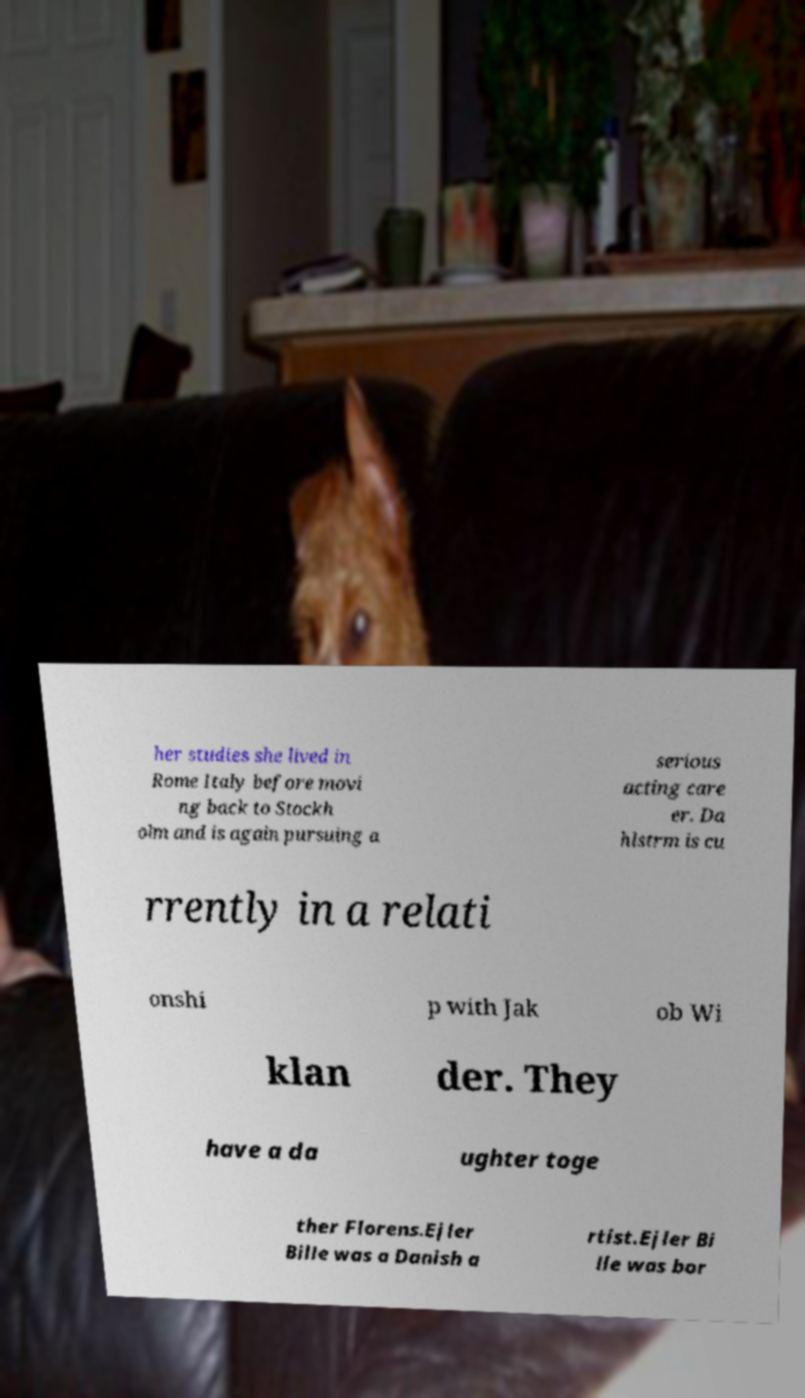Please read and relay the text visible in this image. What does it say? her studies she lived in Rome Italy before movi ng back to Stockh olm and is again pursuing a serious acting care er. Da hlstrm is cu rrently in a relati onshi p with Jak ob Wi klan der. They have a da ughter toge ther Florens.Ejler Bille was a Danish a rtist.Ejler Bi lle was bor 